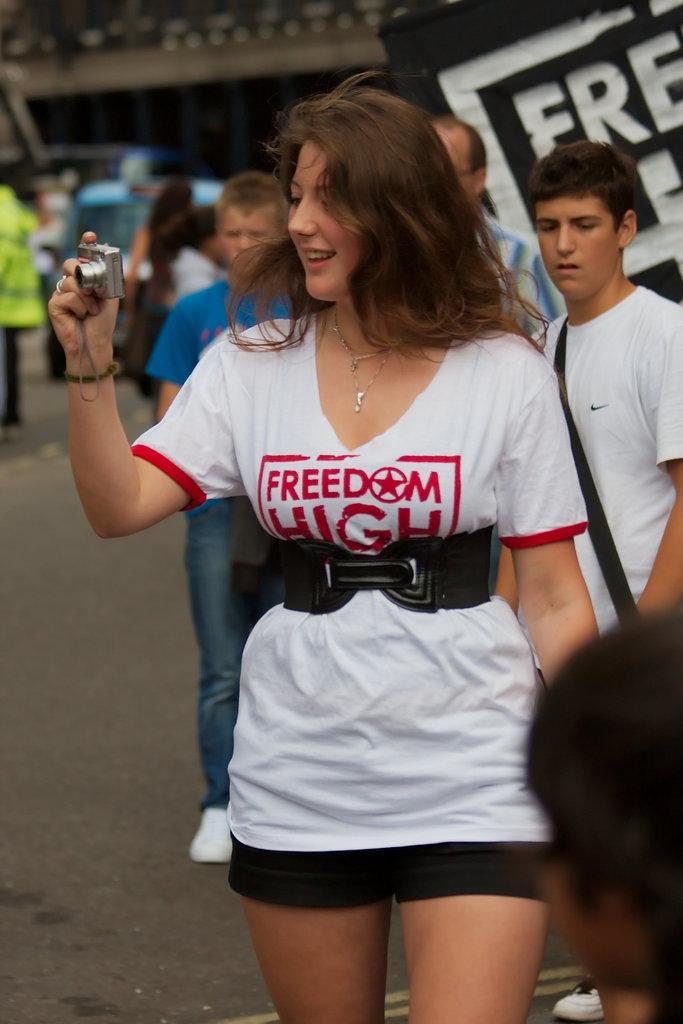<image>
Provide a brief description of the given image. Woman holding a camera and wearing a shirt that says "Freedom High". 